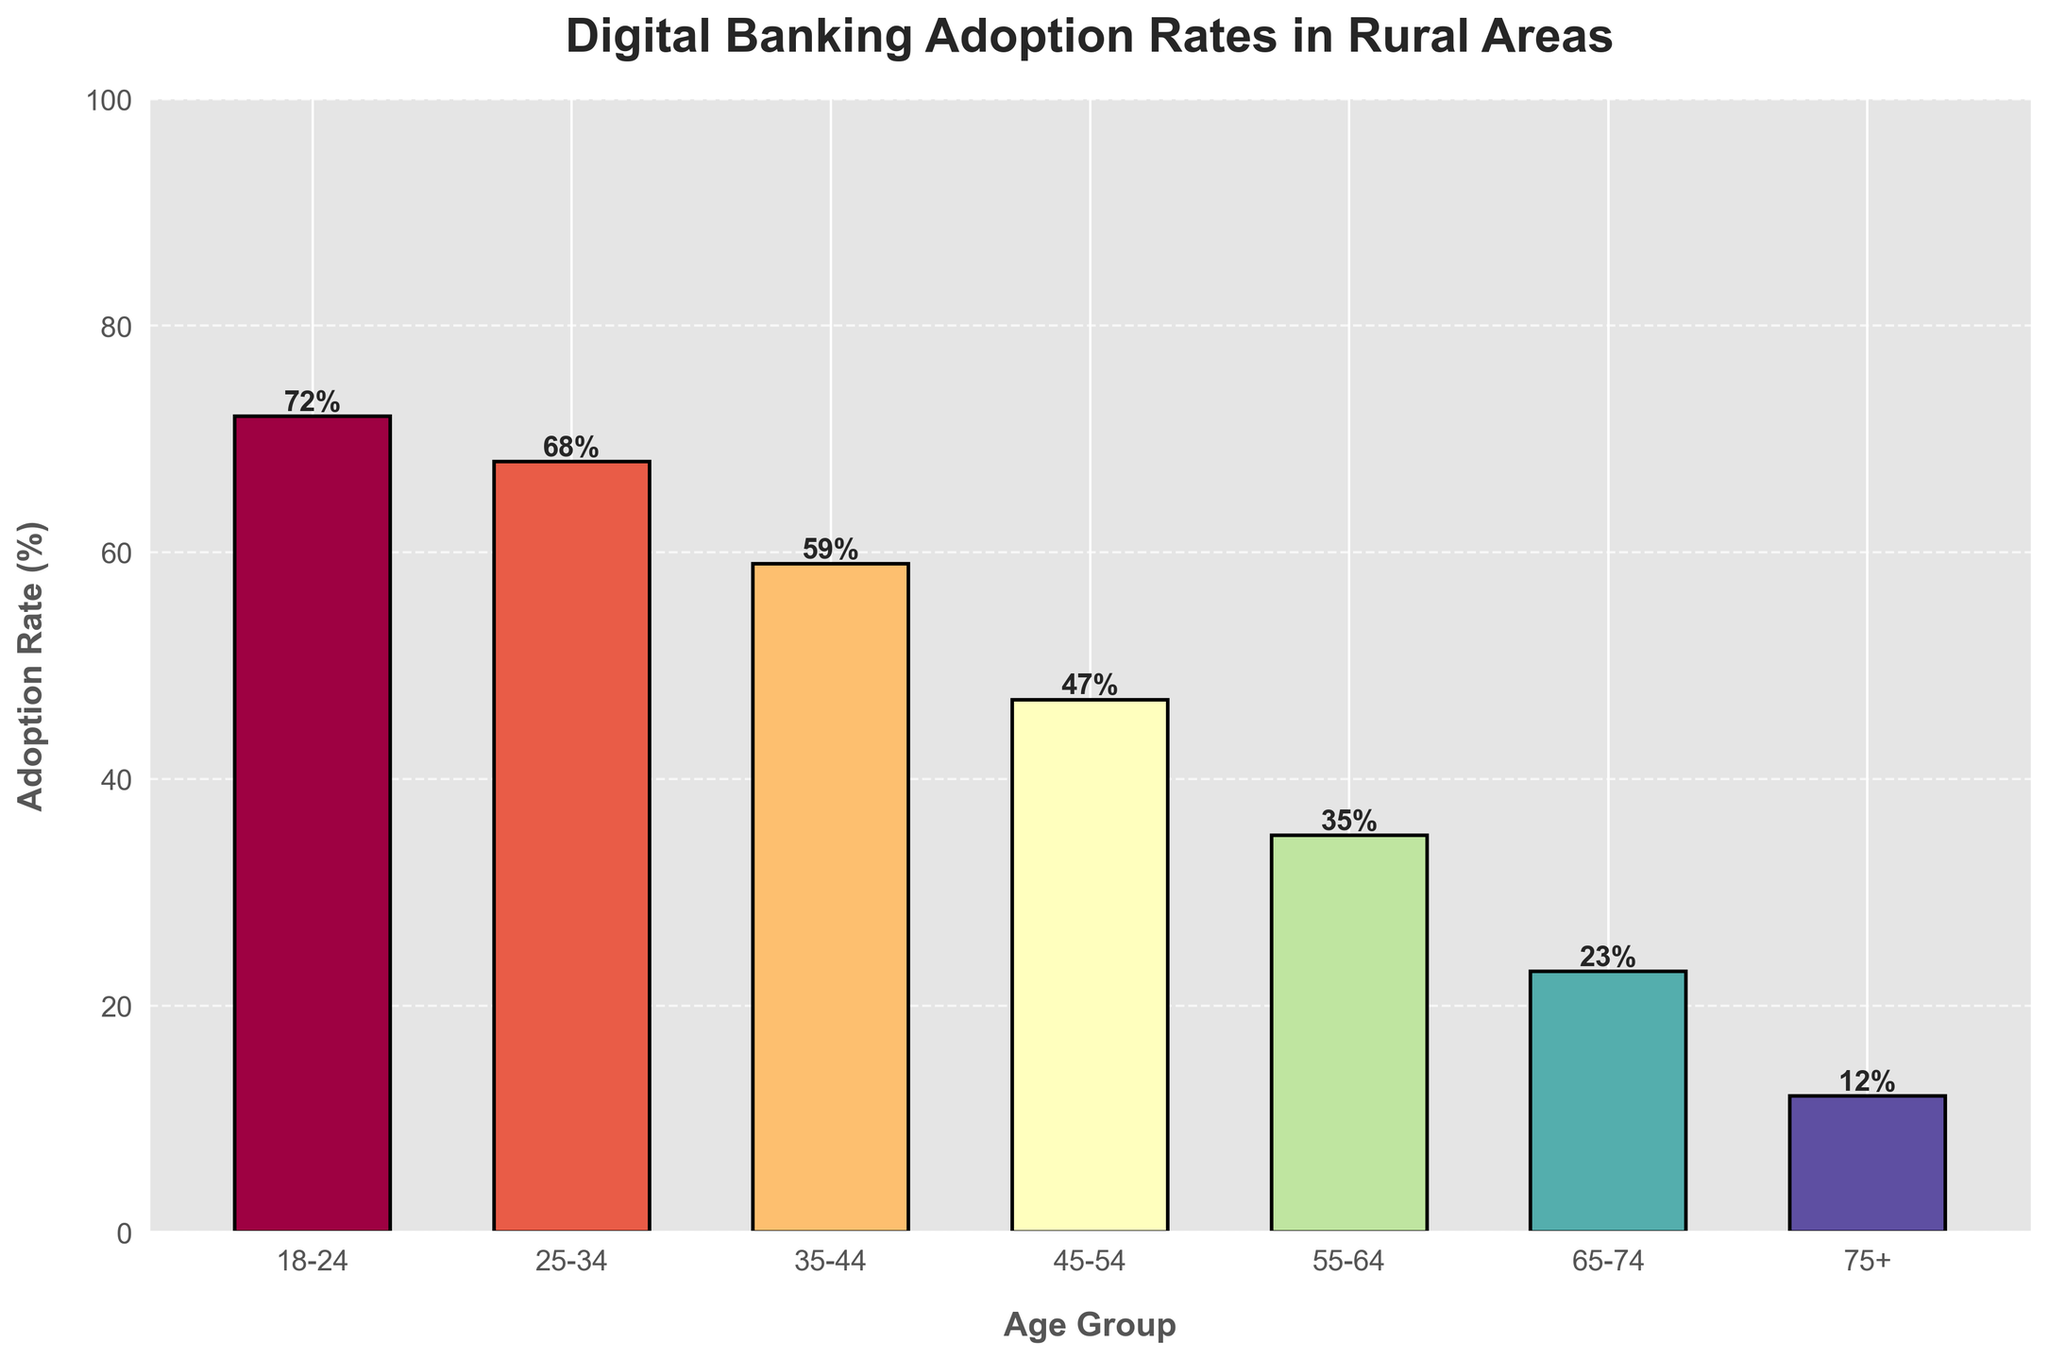What age group has the highest adoption rate of digital banking services? The highest adoption rate can be seen by identifying the tallest bar in the chart. The bar corresponding to the 18-24 age group is the tallest.
Answer: 18-24 What is the difference in adoption rates between the age groups 25-34 and 55-64? Subtract the adoption rate of the 55-64 age group from that of the 25-34 age group (68 - 35).
Answer: 33 What is the average adoption rate across all age groups? To find the average, sum up all the adoption rates and divide by the number of age groups. Sum = 72 + 68 + 59 + 47 + 35 + 23 + 12 = 316. There are 7 age groups, so the average is 316/7.
Answer: 45.14 How much lower is the adoption rate for the 75+ age group compared to the 18-24 age group? Subtract the adoption rate of the 75+ group from that of the 18-24 group (72 - 12).
Answer: 60 What percentage of the total adoption rate is contributed by the age group 45-54? First, sum all adoption rates (316), then divide the 45-54 group's rate by this sum and multiply by 100 to get the percentage. So (47/316) * 100 ≈ 14.87%.
Answer: 14.87% Which age groups have adoption rates greater than 50%? Identify bars that exceed the halfway point of the y-axis (50%). The age groups 18-24, 25-34, and 35-44 have adoption rates greater than 50%.
Answer: 18-24, 25-34, 35-44 By how many percentage points is the adoption rate for the 35-44 age group higher than that of the 65-74 age group? Subtract the adoption rate of the 65-74 group from that of the 35-44 group (59 - 23).
Answer: 36 What is the combined adoption rate for the 55-64 and 65-74 age groups? Add the adoption rates of the 55-64 and 65-74 age groups (35 + 23).
Answer: 58 How does the visual height of the bar for the 35-44 age group compare to that of the 45-54 age group? The bar for the 35-44 age group is taller than the bar for the 45-54 age group, indicating a higher adoption rate.
Answer: Taller What is the median adoption rate among all age groups? Arrange the adoption rates in ascending order (12, 23, 35, 47, 59, 68, 72). The median value, being the middle one, is 47.
Answer: 47 